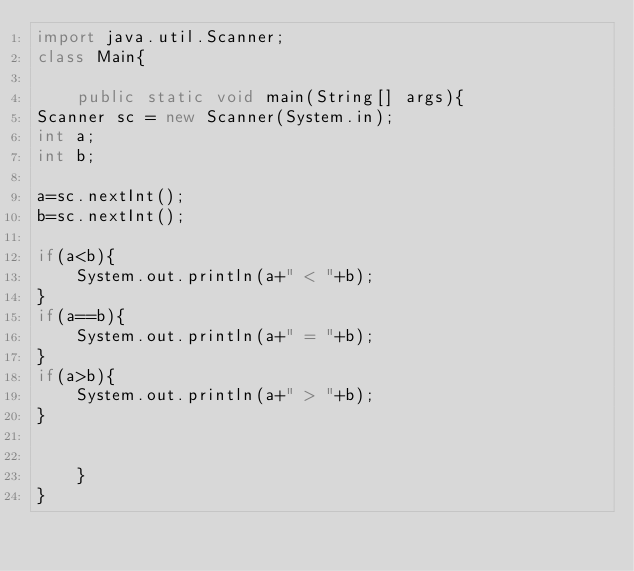Convert code to text. <code><loc_0><loc_0><loc_500><loc_500><_Java_>import java.util.Scanner;
class Main{

	public static void main(String[] args){
Scanner sc = new Scanner(System.in);
int a;
int b;

a=sc.nextInt();
b=sc.nextInt();

if(a<b){
	System.out.println(a+" < "+b);
}
if(a==b){
	System.out.println(a+" = "+b);
}
if(a>b){
	System.out.println(a+" > "+b);
}


    }
}</code> 